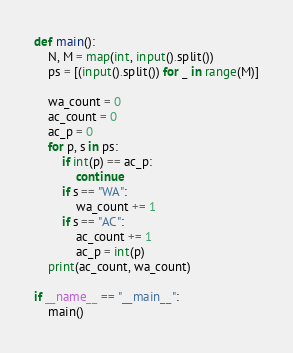<code> <loc_0><loc_0><loc_500><loc_500><_Python_>
def main():
    N, M = map(int, input().split())
    ps = [(input().split()) for _ in range(M)]
    
    wa_count = 0
    ac_count = 0
    ac_p = 0
    for p, s in ps:
        if int(p) == ac_p:
            continue
        if s == "WA":
            wa_count += 1
        if s == "AC":
            ac_count += 1
            ac_p = int(p)
    print(ac_count, wa_count)

if __name__ == "__main__":
    main()</code> 